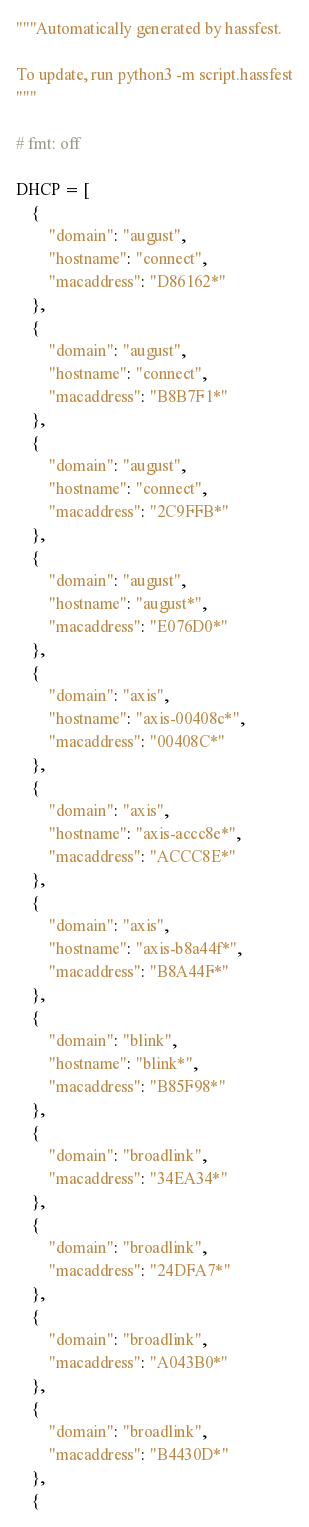Convert code to text. <code><loc_0><loc_0><loc_500><loc_500><_Python_>"""Automatically generated by hassfest.

To update, run python3 -m script.hassfest
"""

# fmt: off

DHCP = [
    {
        "domain": "august",
        "hostname": "connect",
        "macaddress": "D86162*"
    },
    {
        "domain": "august",
        "hostname": "connect",
        "macaddress": "B8B7F1*"
    },
    {
        "domain": "august",
        "hostname": "connect",
        "macaddress": "2C9FFB*"
    },
    {
        "domain": "august",
        "hostname": "august*",
        "macaddress": "E076D0*"
    },
    {
        "domain": "axis",
        "hostname": "axis-00408c*",
        "macaddress": "00408C*"
    },
    {
        "domain": "axis",
        "hostname": "axis-accc8e*",
        "macaddress": "ACCC8E*"
    },
    {
        "domain": "axis",
        "hostname": "axis-b8a44f*",
        "macaddress": "B8A44F*"
    },
    {
        "domain": "blink",
        "hostname": "blink*",
        "macaddress": "B85F98*"
    },
    {
        "domain": "broadlink",
        "macaddress": "34EA34*"
    },
    {
        "domain": "broadlink",
        "macaddress": "24DFA7*"
    },
    {
        "domain": "broadlink",
        "macaddress": "A043B0*"
    },
    {
        "domain": "broadlink",
        "macaddress": "B4430D*"
    },
    {</code> 